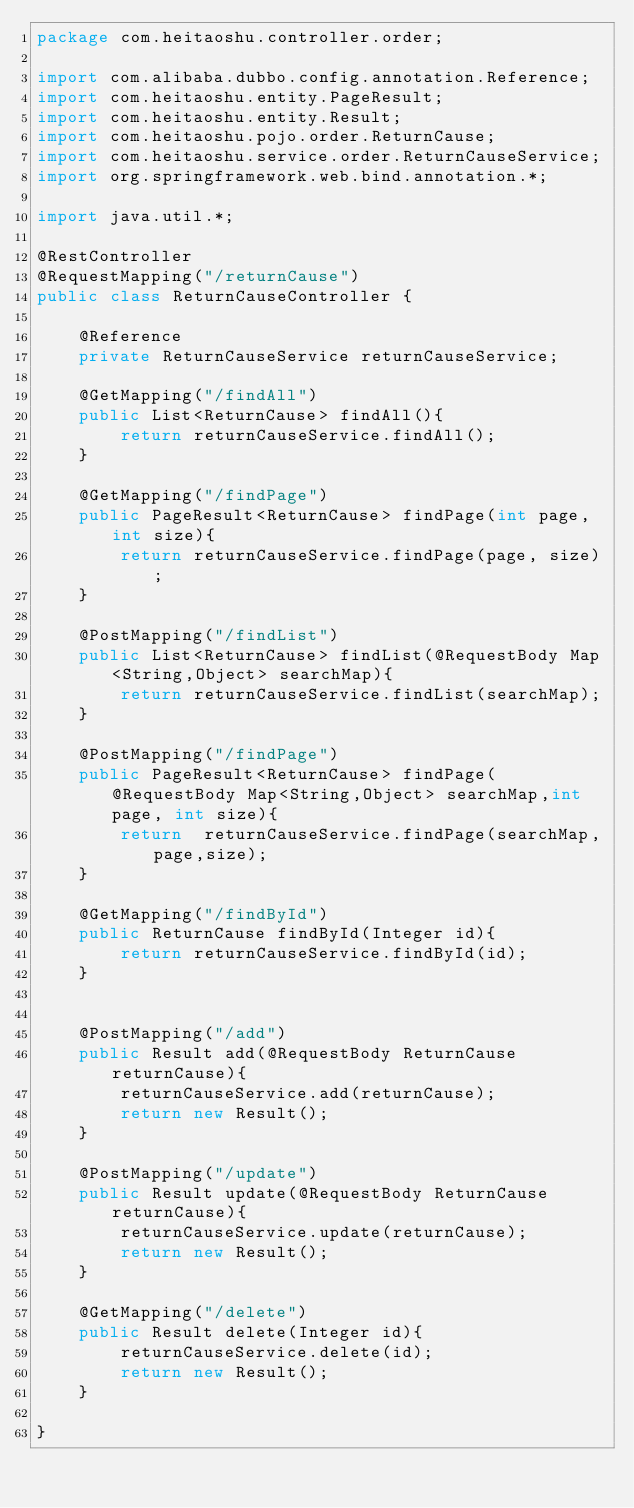Convert code to text. <code><loc_0><loc_0><loc_500><loc_500><_Java_>package com.heitaoshu.controller.order;

import com.alibaba.dubbo.config.annotation.Reference;
import com.heitaoshu.entity.PageResult;
import com.heitaoshu.entity.Result;
import com.heitaoshu.pojo.order.ReturnCause;
import com.heitaoshu.service.order.ReturnCauseService;
import org.springframework.web.bind.annotation.*;

import java.util.*;

@RestController
@RequestMapping("/returnCause")
public class ReturnCauseController {

    @Reference
    private ReturnCauseService returnCauseService;

    @GetMapping("/findAll")
    public List<ReturnCause> findAll(){
        return returnCauseService.findAll();
    }

    @GetMapping("/findPage")
    public PageResult<ReturnCause> findPage(int page, int size){
        return returnCauseService.findPage(page, size);
    }

    @PostMapping("/findList")
    public List<ReturnCause> findList(@RequestBody Map<String,Object> searchMap){
        return returnCauseService.findList(searchMap);
    }

    @PostMapping("/findPage")
    public PageResult<ReturnCause> findPage(@RequestBody Map<String,Object> searchMap,int page, int size){
        return  returnCauseService.findPage(searchMap,page,size);
    }

    @GetMapping("/findById")
    public ReturnCause findById(Integer id){
        return returnCauseService.findById(id);
    }


    @PostMapping("/add")
    public Result add(@RequestBody ReturnCause returnCause){
        returnCauseService.add(returnCause);
        return new Result();
    }

    @PostMapping("/update")
    public Result update(@RequestBody ReturnCause returnCause){
        returnCauseService.update(returnCause);
        return new Result();
    }

    @GetMapping("/delete")
    public Result delete(Integer id){
        returnCauseService.delete(id);
        return new Result();
    }

}
</code> 